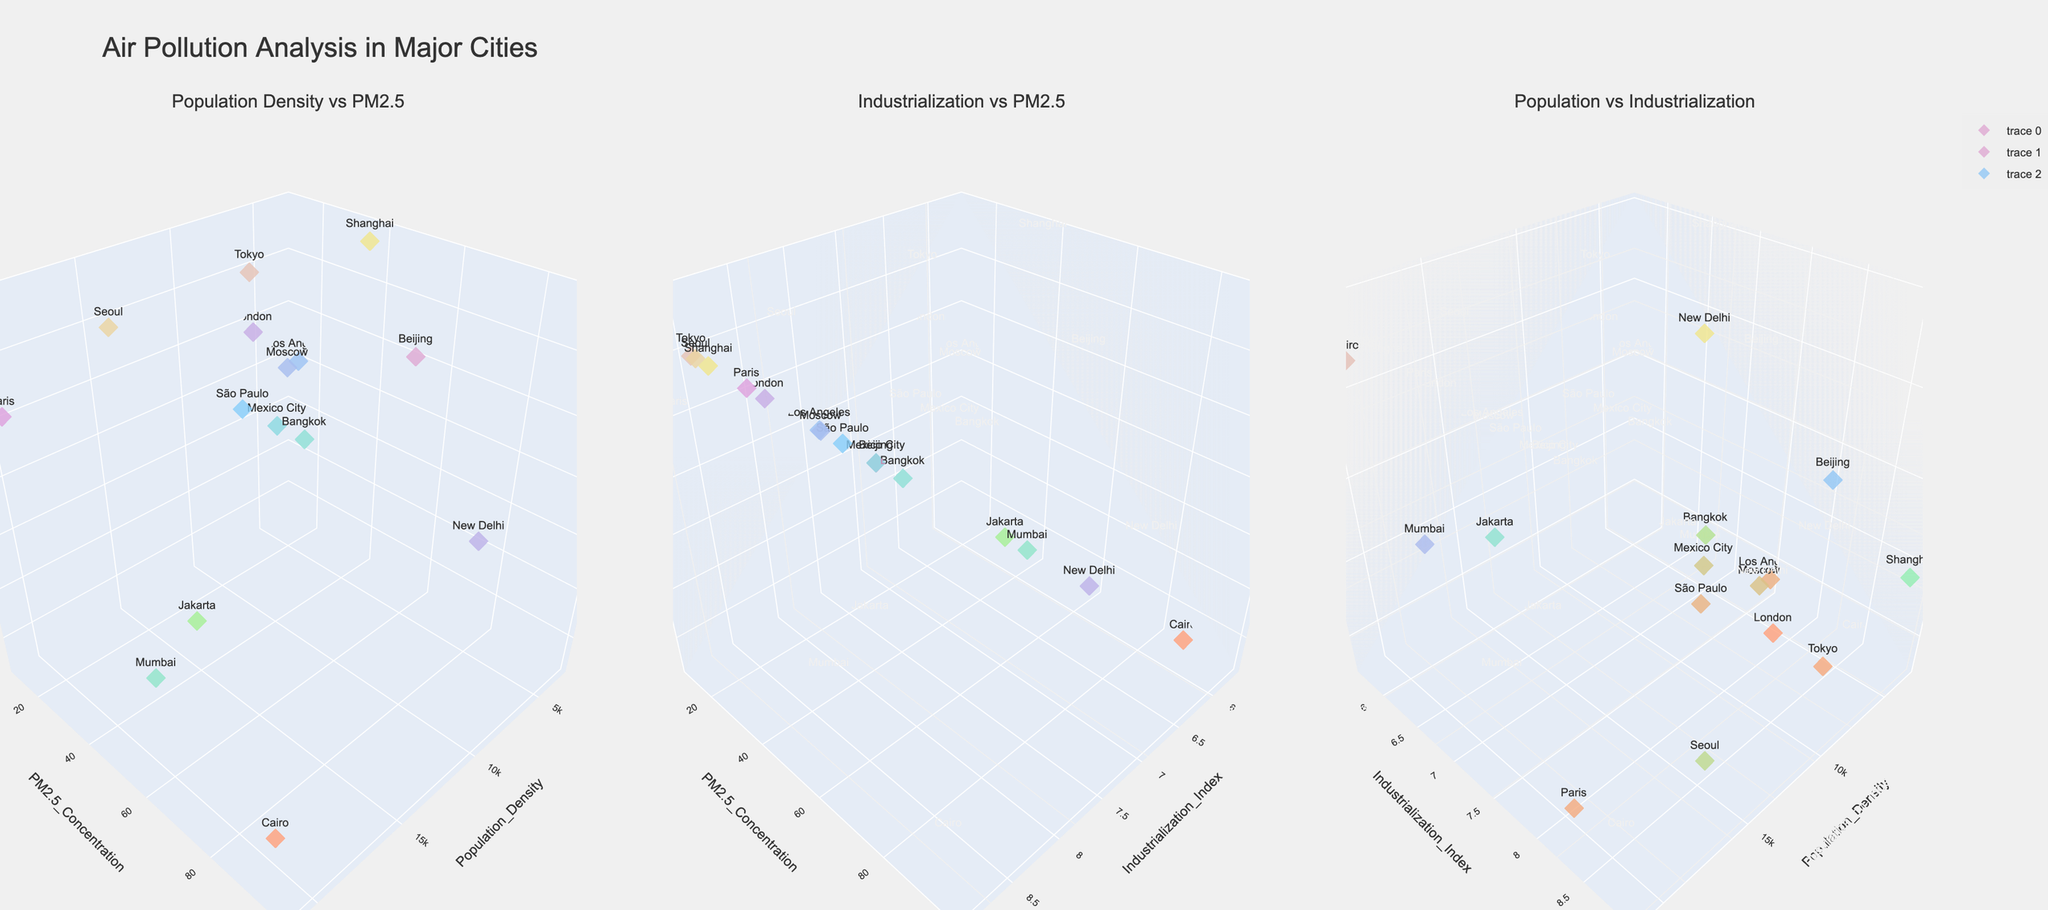What is the title of the figure? The title is displayed prominently at the top of the figure. It is "Air Pollution Analysis in Major Cities".
Answer: Air Pollution Analysis in Major Cities How many subplots are there in the figure? There are three distinct sections, each with its own set of axes and labeled as separate subplots.
Answer: 3 Which subplot shows the relationship between industrialization and PM2.5 concentration? One subplot has "Industrialization vs PM2.5" as its title, indicating it compares the Industrialization Index with PM2.5 Concentration.
Answer: The middle subplot What is the city with the highest population density, and what is its PM2.5 concentration? Upon examining the first subplot (Population Density vs PM2.5), the city with the highest population density appears at the highest point on the x-axis. Hovering over the highest population density point reveals the city's name and its corresponding PM2.5 Concentration.
Answer: Mumbai, 64.1 Which city has the highest PM2.5 concentration? In the first and second subplots where PM2.5 Concentration is displayed along one axis, the city with the highest value can be identified by looking at the tallest point in the z-axis (color scale might also help). This city is New Delhi.
Answer: New Delhi Compare the industrialization index of Seoul and Shanghai. Which city has a higher index? Looking at the three subplots, checking for data points labeled 'Seoul' and 'Shanghai' and their corresponding Industrialization Index values reveals Seoul's value is higher.
Answer: Seoul What is the PM2.5 concentration of Tokyo compared to Los Angeles? Checking their positions in either of the first two subplots with PM2.5 Concentration as an axis shows Tokyo having a PM2.5 Concentration of 13.1 and Los Angeles having a PM2.5 Concentration of 14.8.
Answer: Los Angeles has a higher PM2.5 concentration than Tokyo Is there any city with a population density lower than 5000 and an Industrialization Index higher than 8? Which one? By examining the first and third subplots, any city with Population Density < 5000 and a high Industrialization Index is identified. These plots indicate that such a city is Beijing and Shanghai.
Answer: Beijing, Shanghai (Accept any, as Joins are possible) Which subplot shows the relationship between Population Density, PM2.5 Concentration, and Industrialization Index? The subplot titles clarify this, the ones including both Population Density and PM2.5 Concentration as axes, supplemented by Industrialization as a color scale (z-axis).
Answer: Both the first and third subplots Which city represents the intersection of high industrialization with relatively low PM2.5 concentration? Analyzing the second subplot where cities with high Industrialization and low PM2.5 Concentration are at the upper end of the x-axis with lower z-axis values. 'Tokyo' fits this criterion.
Answer: Tokyo 